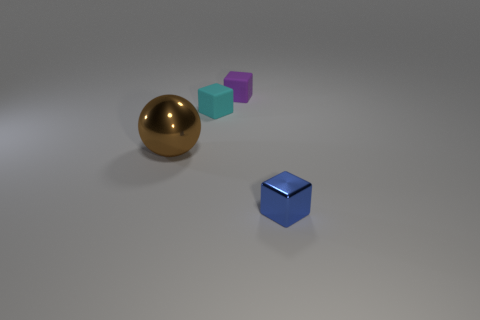There is a small matte cube that is to the left of the small matte thing right of the tiny cyan object; what color is it?
Your response must be concise. Cyan. Are there any tiny matte cubes that have the same color as the small metallic cube?
Your response must be concise. No. What color is the rubber block that is the same size as the cyan rubber thing?
Give a very brief answer. Purple. Is the material of the tiny object to the left of the small purple thing the same as the brown sphere?
Offer a terse response. No. Are there any blue objects that are in front of the thing in front of the brown shiny object that is in front of the tiny cyan rubber cube?
Your answer should be compact. No. Is the shape of the thing that is in front of the big brown shiny thing the same as  the purple object?
Offer a terse response. Yes. There is a matte object that is behind the cyan block that is behind the large sphere; what is its shape?
Your answer should be compact. Cube. What size is the shiny object in front of the metal object that is to the left of the tiny blue thing in front of the tiny cyan matte thing?
Ensure brevity in your answer.  Small. What color is the other tiny matte thing that is the same shape as the small cyan rubber thing?
Provide a succinct answer. Purple. Is the brown shiny thing the same size as the blue block?
Your answer should be compact. No. 